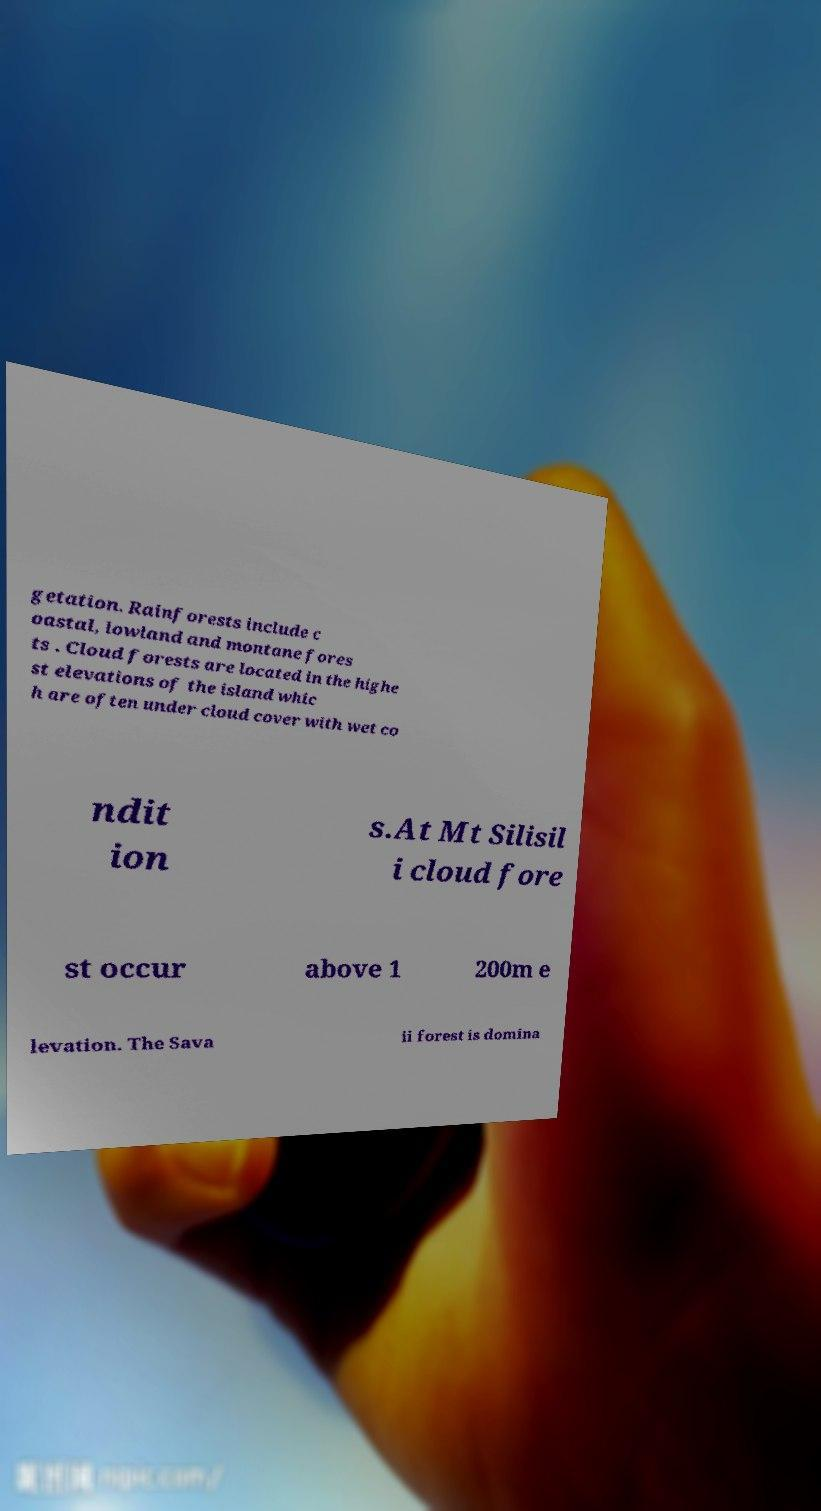Could you extract and type out the text from this image? getation. Rainforests include c oastal, lowland and montane fores ts . Cloud forests are located in the highe st elevations of the island whic h are often under cloud cover with wet co ndit ion s.At Mt Silisil i cloud fore st occur above 1 200m e levation. The Sava ii forest is domina 